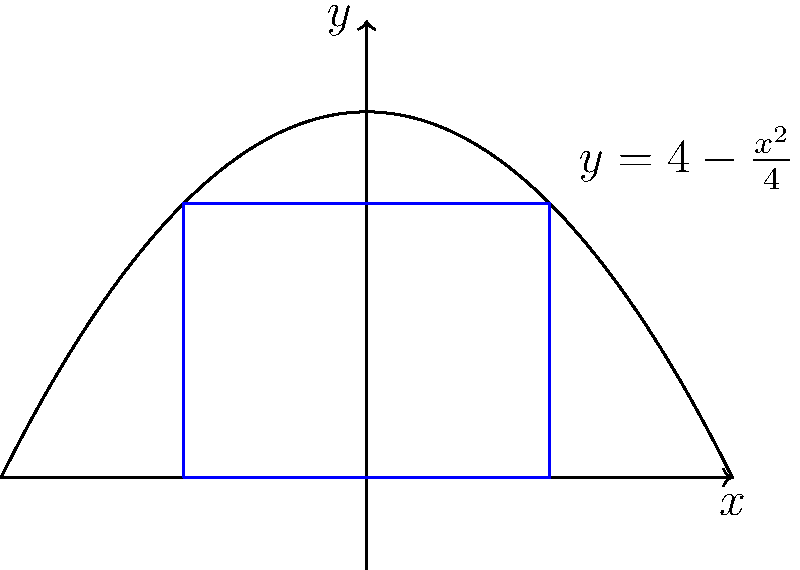Consider a parabola given by the equation $y = 4 - \frac{x^2}{4}$. Find the dimensions of the rectangle with the largest area that can be inscribed in this parabola, with its base on the x-axis and its top corners touching the parabola. Let's approach this step-by-step:

1) Let the width of the rectangle be $2x$ (from $-x$ to $x$ on the x-axis) and its height be $y$.

2) The top corners of the rectangle touch the parabola, so they satisfy the equation:

   $y = 4 - \frac{x^2}{4}$

3) The area of the rectangle is:

   $A = 2xy = 2x(4 - \frac{x^2}{4}) = 8x - \frac{x^3}{2}$

4) To find the maximum area, we differentiate $A$ with respect to $x$ and set it to zero:

   $\frac{dA}{dx} = 8 - \frac{3x^2}{2} = 0$

5) Solving this equation:

   $8 - \frac{3x^2}{2} = 0$
   $\frac{3x^2}{2} = 8$
   $x^2 = \frac{16}{3}$
   $x = \pm \frac{4}{\sqrt{3}}$

6) Since we're looking for a positive width, we take the positive solution:

   $x = \frac{4}{\sqrt{3}}$

7) The height of the rectangle at this $x$ value is:

   $y = 4 - \frac{x^2}{4} = 4 - \frac{16/3}{4} = 4 - \frac{4}{3} = \frac{8}{3}$

8) Therefore, the dimensions of the rectangle are:

   Width = $2x = \frac{8}{\sqrt{3}}$
   Height = $y = \frac{8}{3}$
Answer: Width = $\frac{8}{\sqrt{3}}$, Height = $\frac{8}{3}$ 